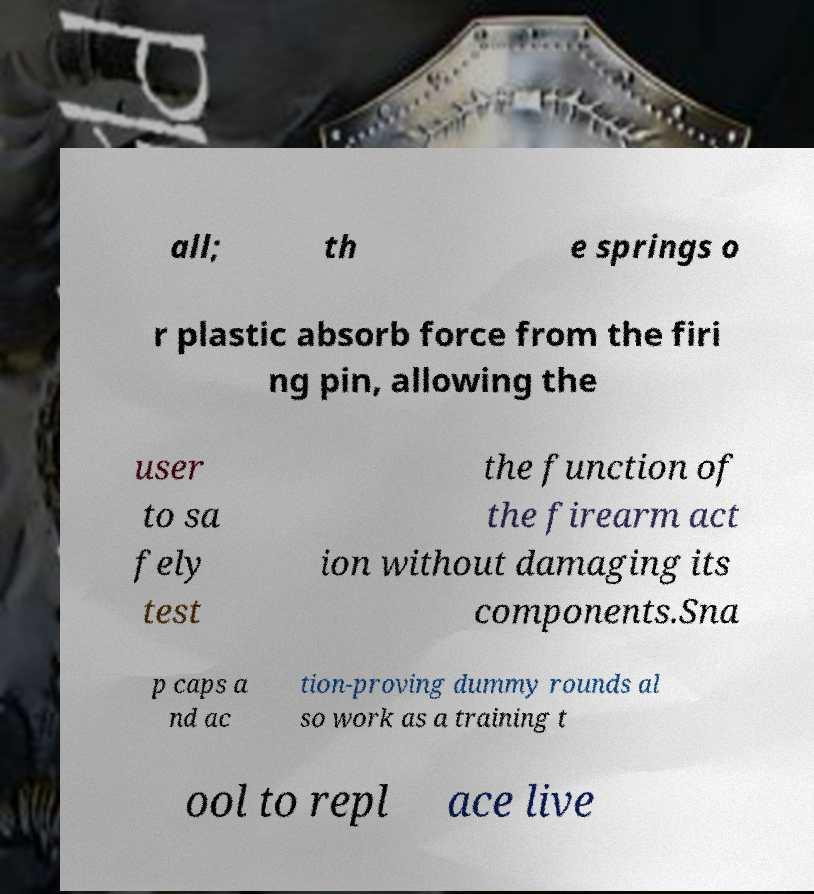For documentation purposes, I need the text within this image transcribed. Could you provide that? all; th e springs o r plastic absorb force from the firi ng pin, allowing the user to sa fely test the function of the firearm act ion without damaging its components.Sna p caps a nd ac tion-proving dummy rounds al so work as a training t ool to repl ace live 